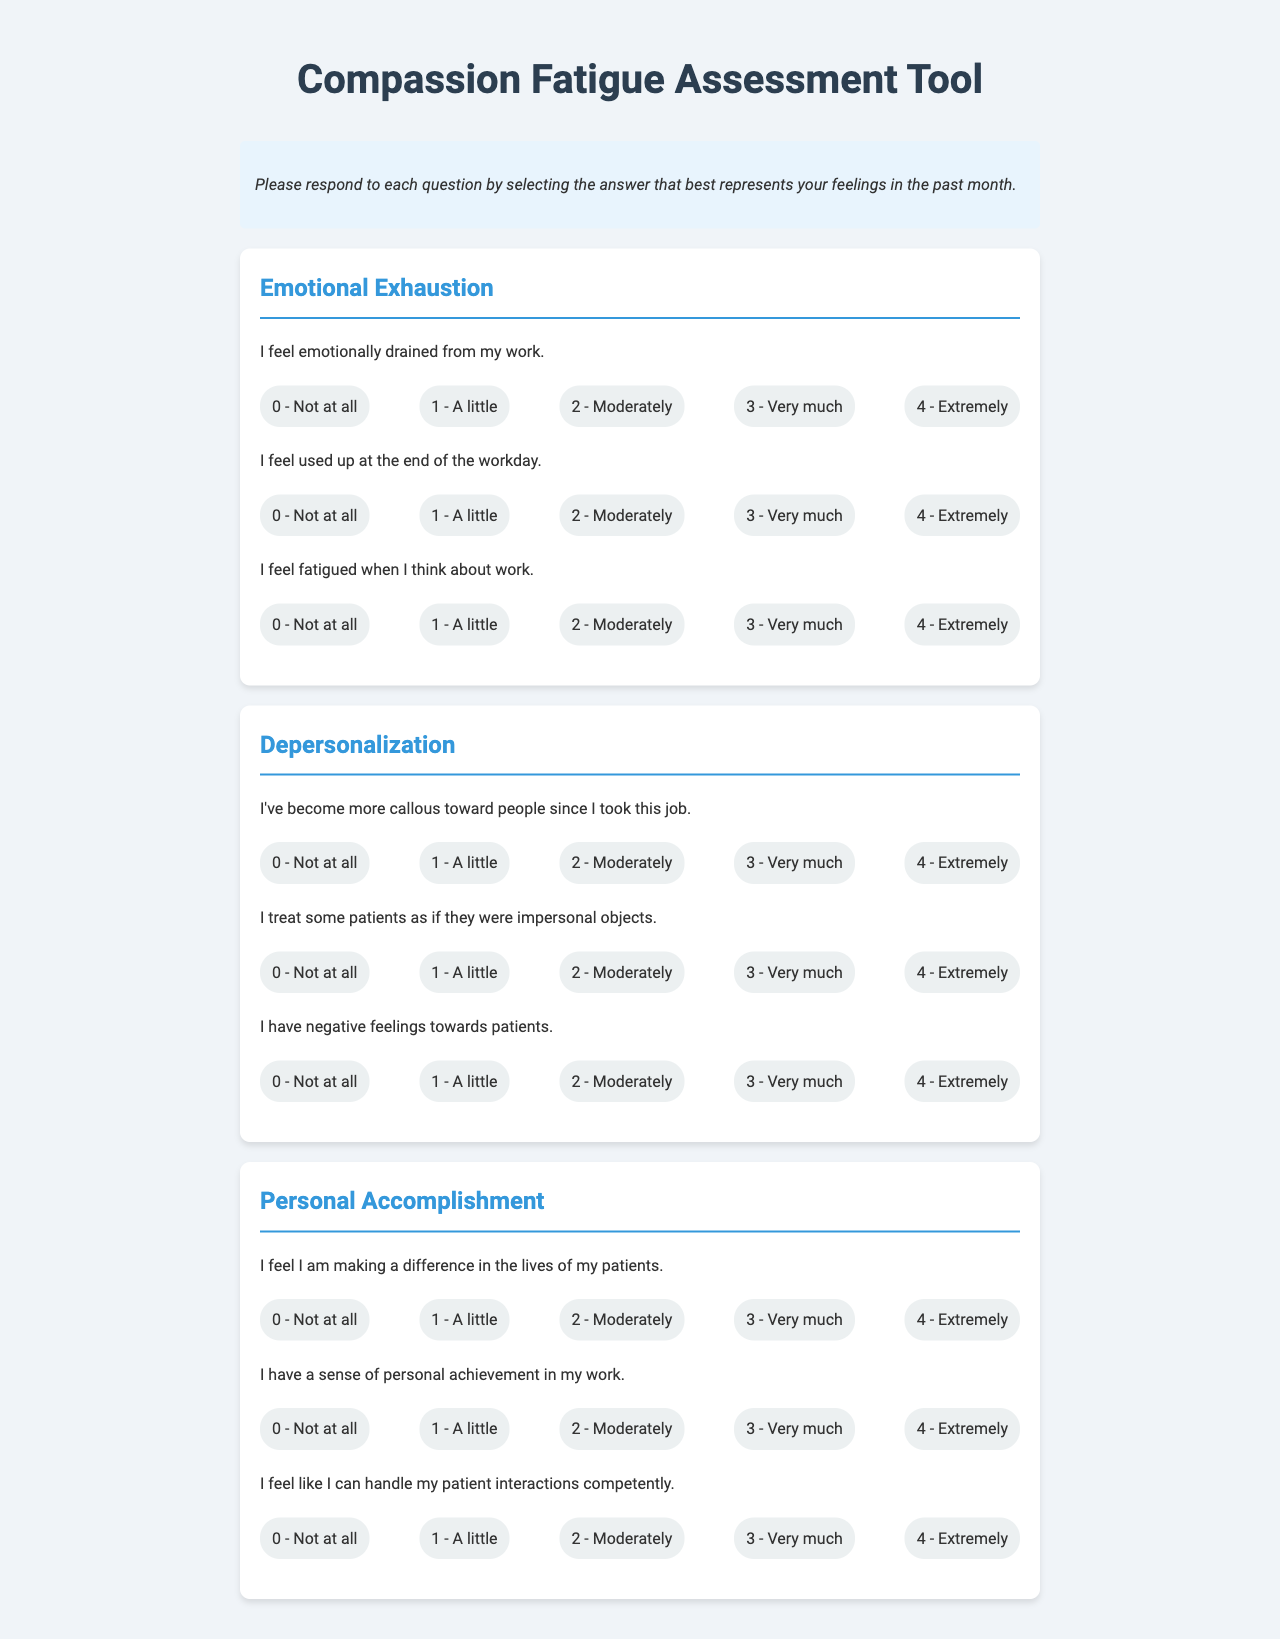What is the title of the document? The title is found at the top of the rendered document, indicating the main purpose of the form.
Answer: Compassion Fatigue Assessment Tool How many sections are in the form? The form contains three distinct sections, each representing different aspects of compassion fatigue.
Answer: Three What scale is used for responding to the questions? The scale is provided alongside each question and is indicated by the frequency and intensity of feelings about the statements.
Answer: 0 to 4 Which section includes questions about "callous" behavior? This information relates to how one may feel about their interactions with others and is detailed in the specific section addressing this aspect.
Answer: Depersonalization What response indicates feeling "emotionally drained"? The assessment includes questions aimed at identifying specific feelings associated with work, and responses related to emotional exhaustion help gauge this experience.
Answer: 3 - Very much 